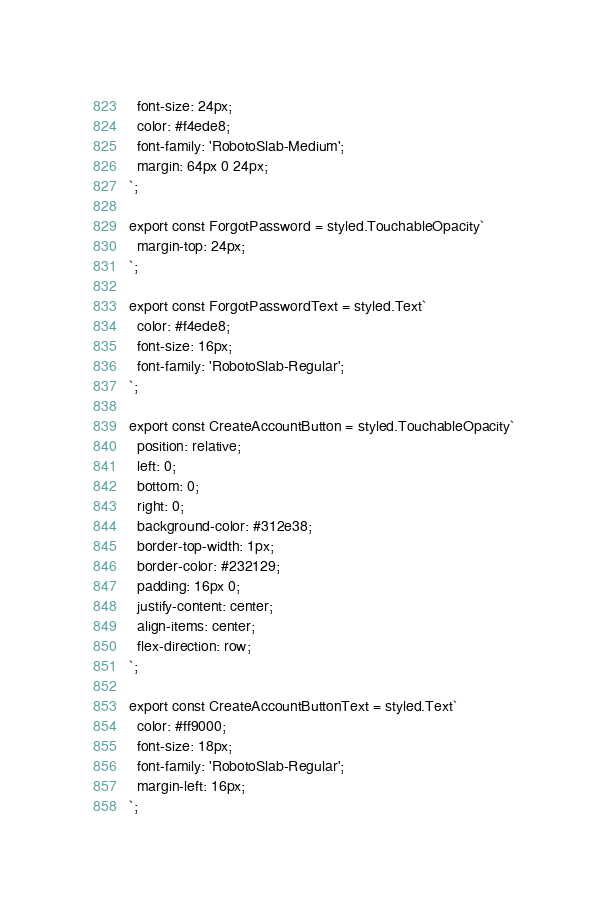<code> <loc_0><loc_0><loc_500><loc_500><_TypeScript_>  font-size: 24px;
  color: #f4ede8;
  font-family: 'RobotoSlab-Medium';
  margin: 64px 0 24px;
`;

export const ForgotPassword = styled.TouchableOpacity`
  margin-top: 24px;
`;

export const ForgotPasswordText = styled.Text`
  color: #f4ede8;
  font-size: 16px;
  font-family: 'RobotoSlab-Regular';
`;

export const CreateAccountButton = styled.TouchableOpacity`
  position: relative;
  left: 0;
  bottom: 0;
  right: 0;
  background-color: #312e38;
  border-top-width: 1px;
  border-color: #232129;
  padding: 16px 0;
  justify-content: center;
  align-items: center;
  flex-direction: row;
`;

export const CreateAccountButtonText = styled.Text`
  color: #ff9000;
  font-size: 18px;
  font-family: 'RobotoSlab-Regular';
  margin-left: 16px;
`;
</code> 